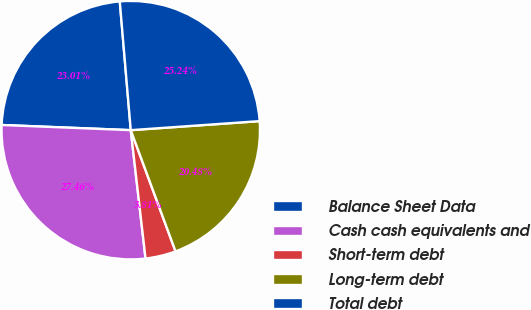Convert chart to OTSL. <chart><loc_0><loc_0><loc_500><loc_500><pie_chart><fcel>Balance Sheet Data<fcel>Cash cash equivalents and<fcel>Short-term debt<fcel>Long-term debt<fcel>Total debt<nl><fcel>23.01%<fcel>27.46%<fcel>3.81%<fcel>20.48%<fcel>25.24%<nl></chart> 